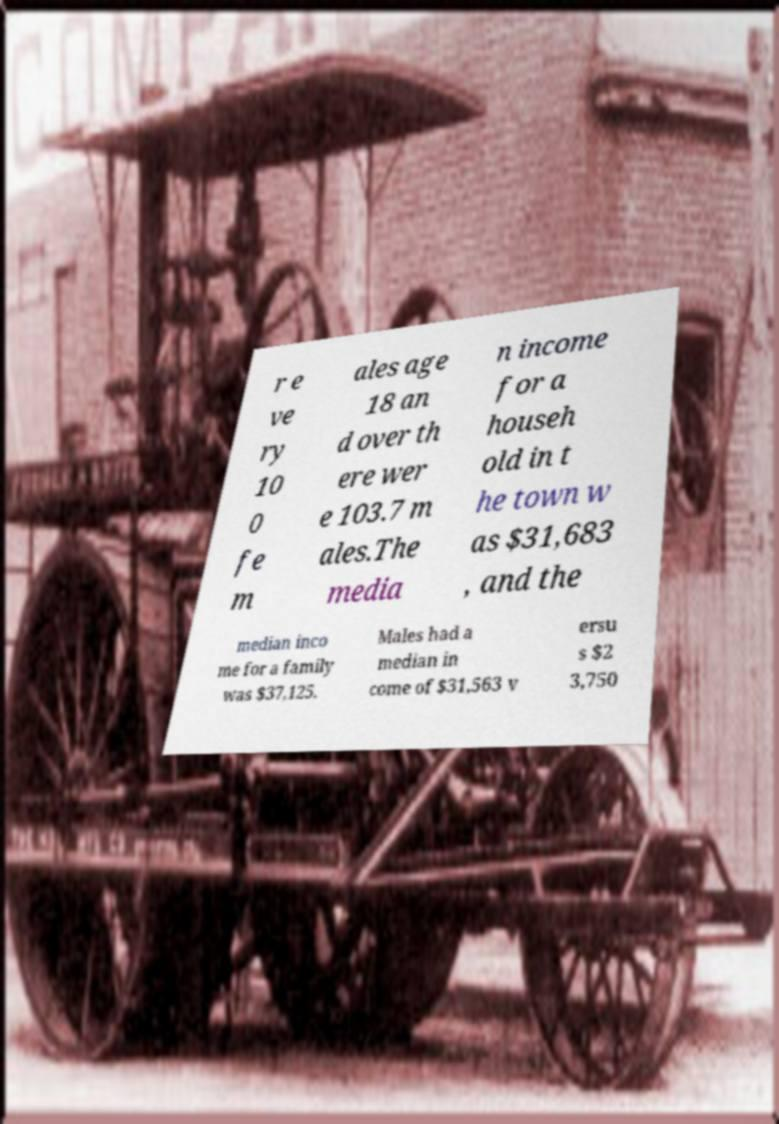Can you accurately transcribe the text from the provided image for me? r e ve ry 10 0 fe m ales age 18 an d over th ere wer e 103.7 m ales.The media n income for a househ old in t he town w as $31,683 , and the median inco me for a family was $37,125. Males had a median in come of $31,563 v ersu s $2 3,750 